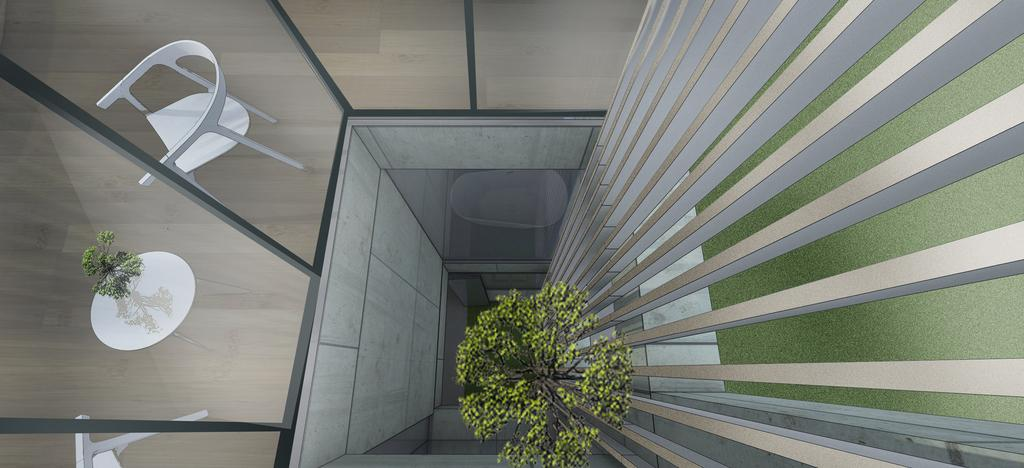What is the perspective of the image? The image is a view from the top of a building. What can be seen on the right side of the image? There are pillars and a tree on the right side of the image. What type of walls are visible in the image? There are glass walls visible in the image. What can be seen through the glass walls? A table and chairs are visible through the glass walls. How does the organization of the pillars compare to the organization of the chairs in the image? There is no comparison made between the organization of the pillars and the chairs in the image, as the question is not based on the provided facts. 